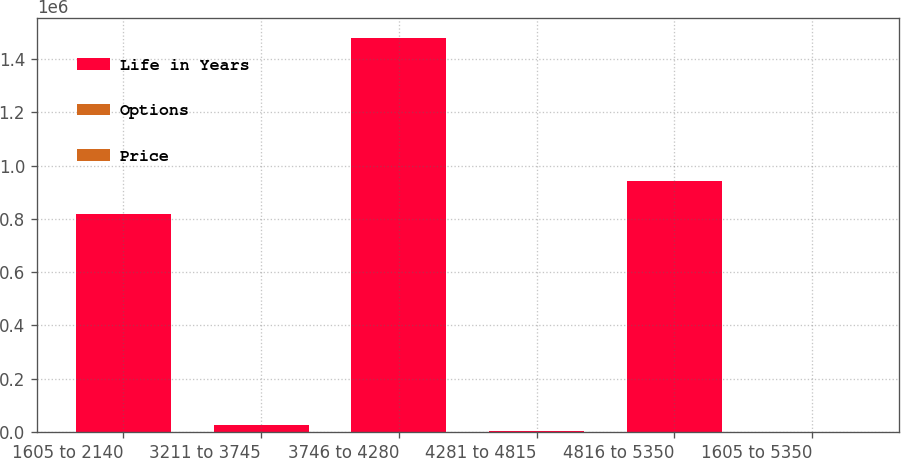Convert chart to OTSL. <chart><loc_0><loc_0><loc_500><loc_500><stacked_bar_chart><ecel><fcel>1605 to 2140<fcel>3211 to 3745<fcel>3746 to 4280<fcel>4281 to 4815<fcel>4816 to 5350<fcel>1605 to 5350<nl><fcel>Life in Years<fcel>817375<fcel>26047<fcel>1.48129e+06<fcel>3992<fcel>943693<fcel>32.54<nl><fcel>Options<fcel>1.53<fcel>6.75<fcel>7.98<fcel>8.51<fcel>8.96<fcel>5.74<nl><fcel>Price<fcel>20.55<fcel>32.54<fcel>42.12<fcel>45.33<fcel>53.5<fcel>32.37<nl></chart> 